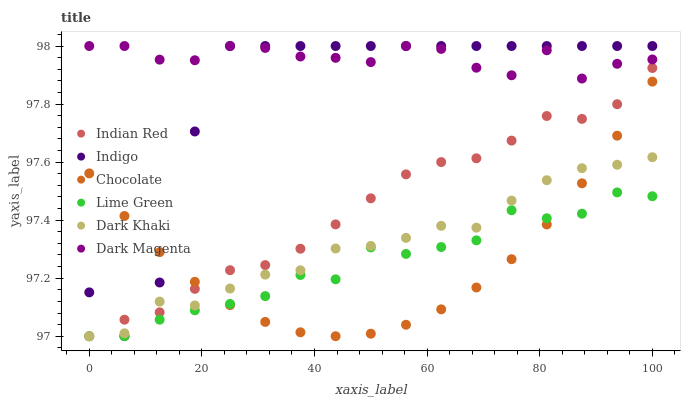Does Chocolate have the minimum area under the curve?
Answer yes or no. Yes. Does Dark Magenta have the maximum area under the curve?
Answer yes or no. Yes. Does Dark Magenta have the minimum area under the curve?
Answer yes or no. No. Does Chocolate have the maximum area under the curve?
Answer yes or no. No. Is Chocolate the smoothest?
Answer yes or no. Yes. Is Indigo the roughest?
Answer yes or no. Yes. Is Dark Magenta the smoothest?
Answer yes or no. No. Is Dark Magenta the roughest?
Answer yes or no. No. Does Dark Khaki have the lowest value?
Answer yes or no. Yes. Does Chocolate have the lowest value?
Answer yes or no. No. Does Dark Magenta have the highest value?
Answer yes or no. Yes. Does Chocolate have the highest value?
Answer yes or no. No. Is Lime Green less than Indigo?
Answer yes or no. Yes. Is Dark Magenta greater than Indian Red?
Answer yes or no. Yes. Does Dark Khaki intersect Chocolate?
Answer yes or no. Yes. Is Dark Khaki less than Chocolate?
Answer yes or no. No. Is Dark Khaki greater than Chocolate?
Answer yes or no. No. Does Lime Green intersect Indigo?
Answer yes or no. No. 